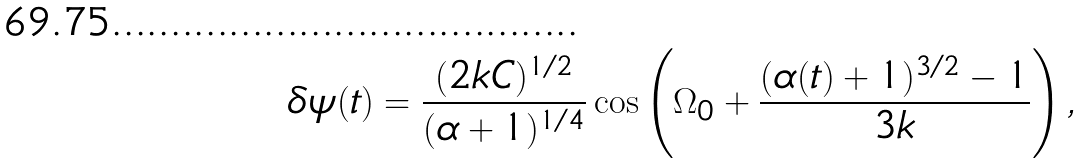Convert formula to latex. <formula><loc_0><loc_0><loc_500><loc_500>\delta \psi ( t ) = \frac { ( 2 k C ) ^ { 1 / 2 } } { ( \alpha + 1 ) ^ { 1 / 4 } } \cos \left ( \Omega _ { 0 } + \frac { ( \alpha ( t ) + 1 ) ^ { 3 / 2 } - 1 } { 3 k } \right ) ,</formula> 